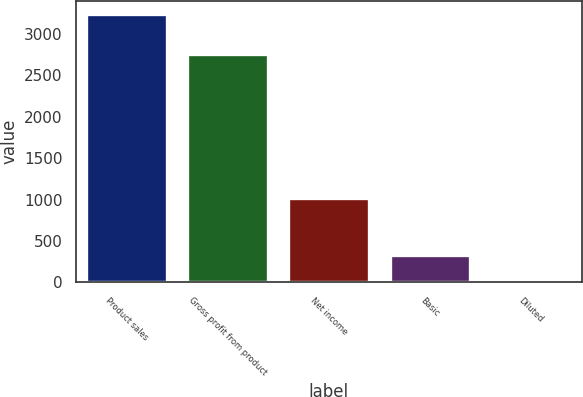Convert chart. <chart><loc_0><loc_0><loc_500><loc_500><bar_chart><fcel>Product sales<fcel>Gross profit from product<fcel>Net income<fcel>Basic<fcel>Diluted<nl><fcel>3238<fcel>2761<fcel>1019<fcel>324.68<fcel>0.98<nl></chart> 